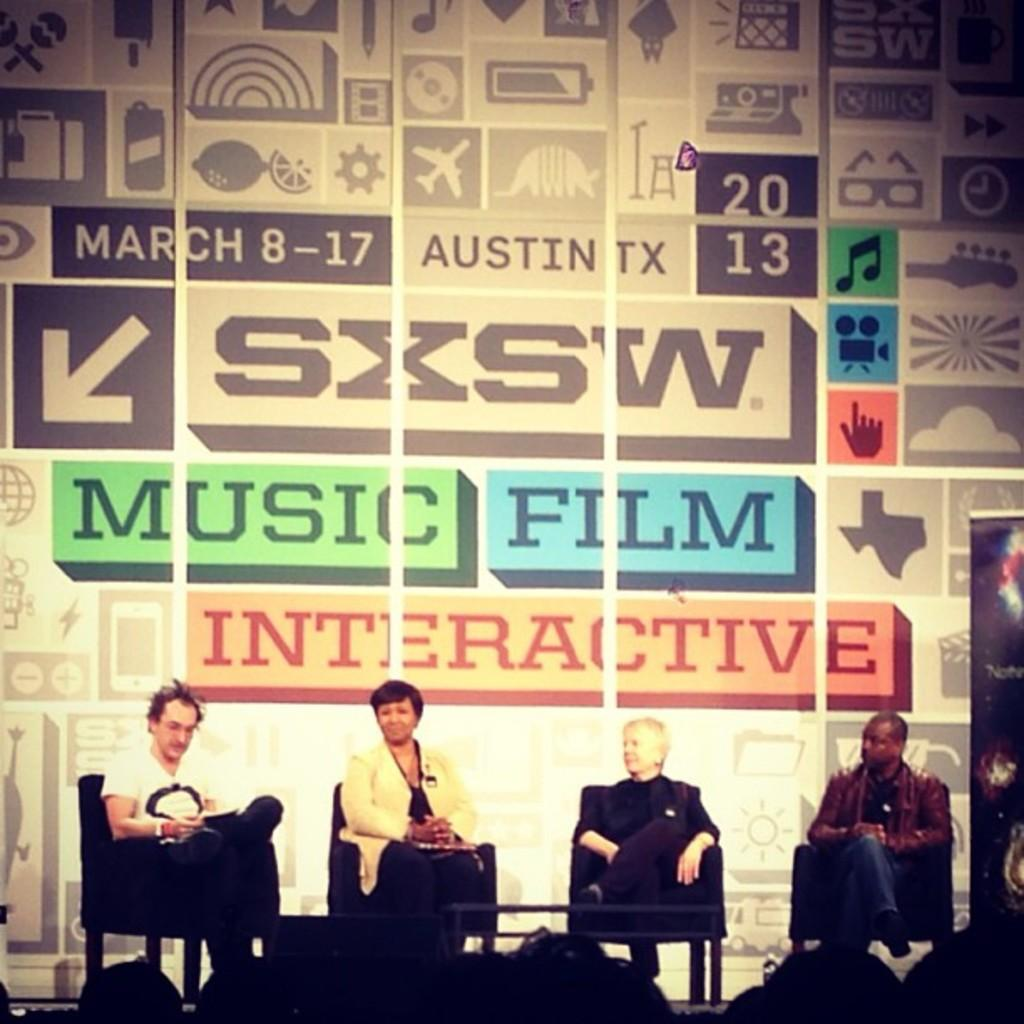How many people are sitting in the foreground of the image? There are four people sitting on chairs in the foreground of the image. What can be seen at the top of the image? There is a banner visible at the top of the image. What is written on the banner? Text is written on the banner. Is there steam coming out of the birthday cake in the image? There is no birthday cake or steam present in the image. What type of advertisement is being displayed on the banner? The provided facts do not mention any advertisement or specific content on the banner, so we cannot determine the type of advertisement. 